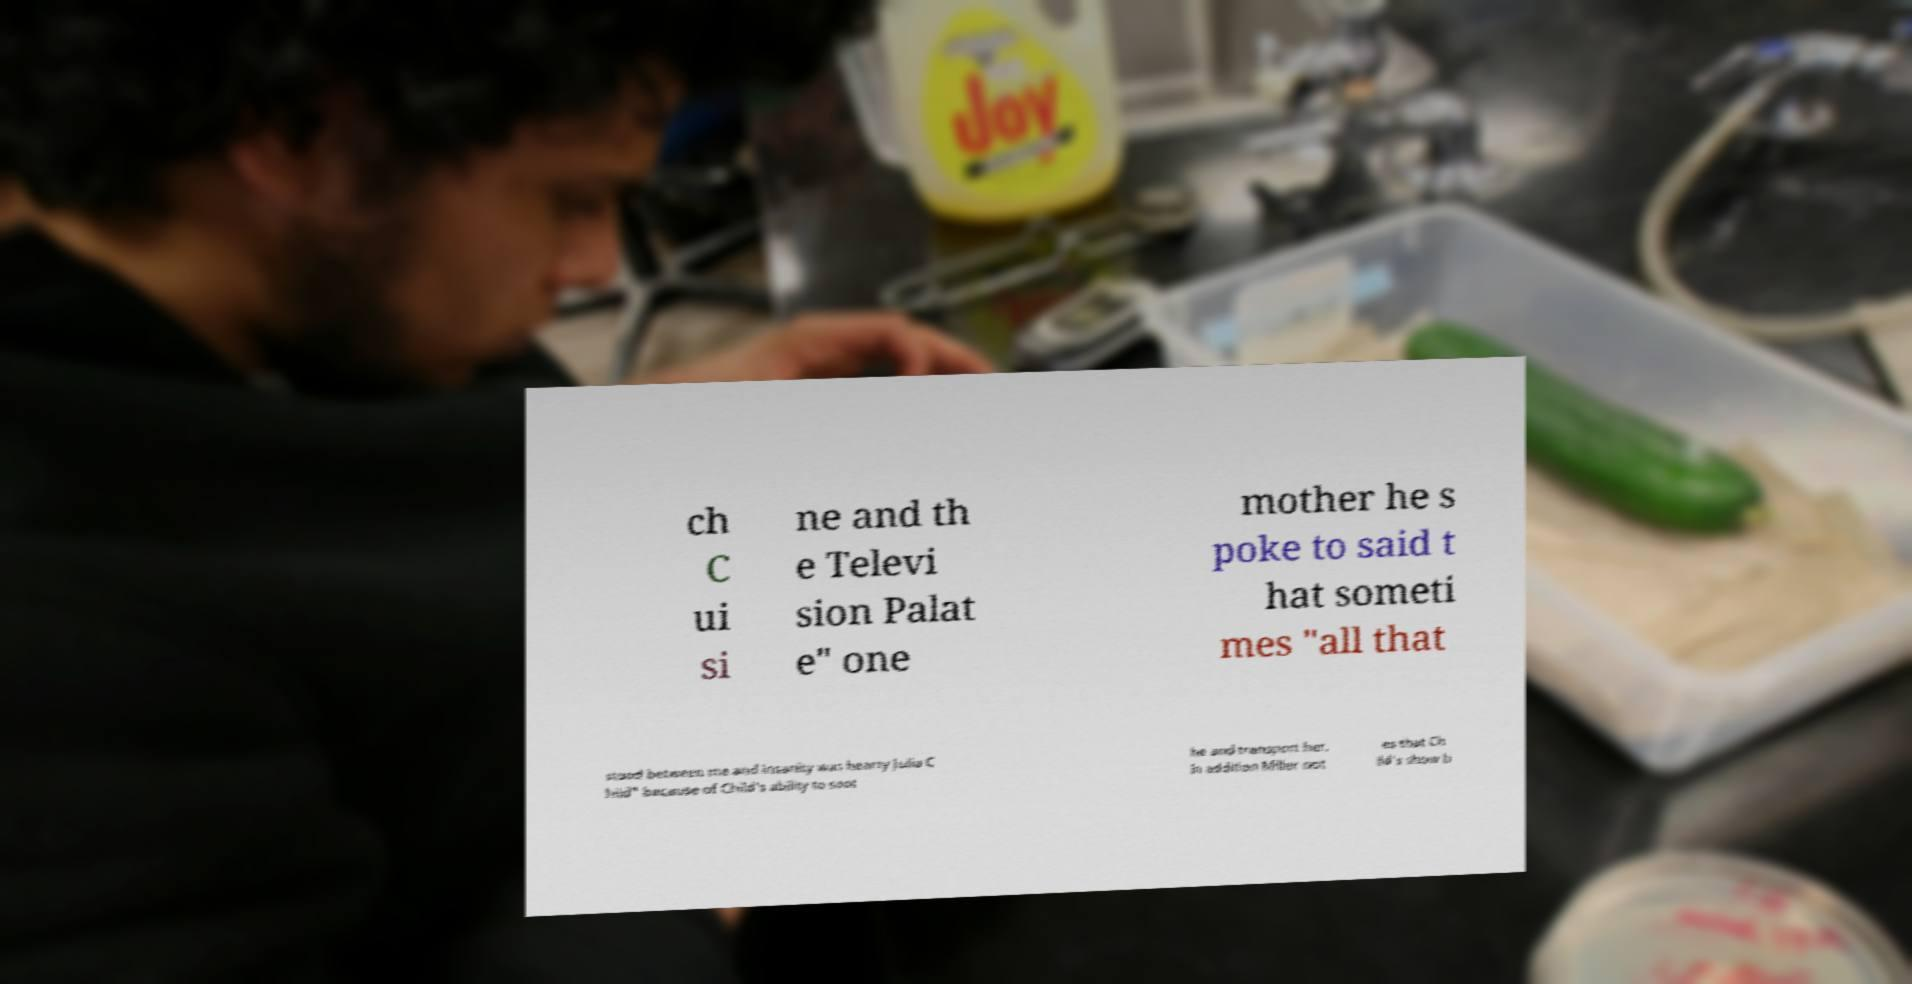Could you assist in decoding the text presented in this image and type it out clearly? ch C ui si ne and th e Televi sion Palat e" one mother he s poke to said t hat someti mes "all that stood between me and insanity was hearty Julia C hild" because of Child's ability to soot he and transport her. In addition Miller not es that Ch ild's show b 